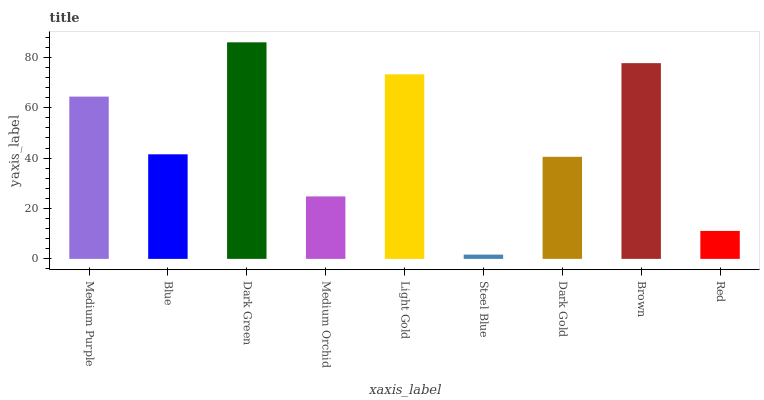Is Steel Blue the minimum?
Answer yes or no. Yes. Is Dark Green the maximum?
Answer yes or no. Yes. Is Blue the minimum?
Answer yes or no. No. Is Blue the maximum?
Answer yes or no. No. Is Medium Purple greater than Blue?
Answer yes or no. Yes. Is Blue less than Medium Purple?
Answer yes or no. Yes. Is Blue greater than Medium Purple?
Answer yes or no. No. Is Medium Purple less than Blue?
Answer yes or no. No. Is Blue the high median?
Answer yes or no. Yes. Is Blue the low median?
Answer yes or no. Yes. Is Red the high median?
Answer yes or no. No. Is Dark Green the low median?
Answer yes or no. No. 